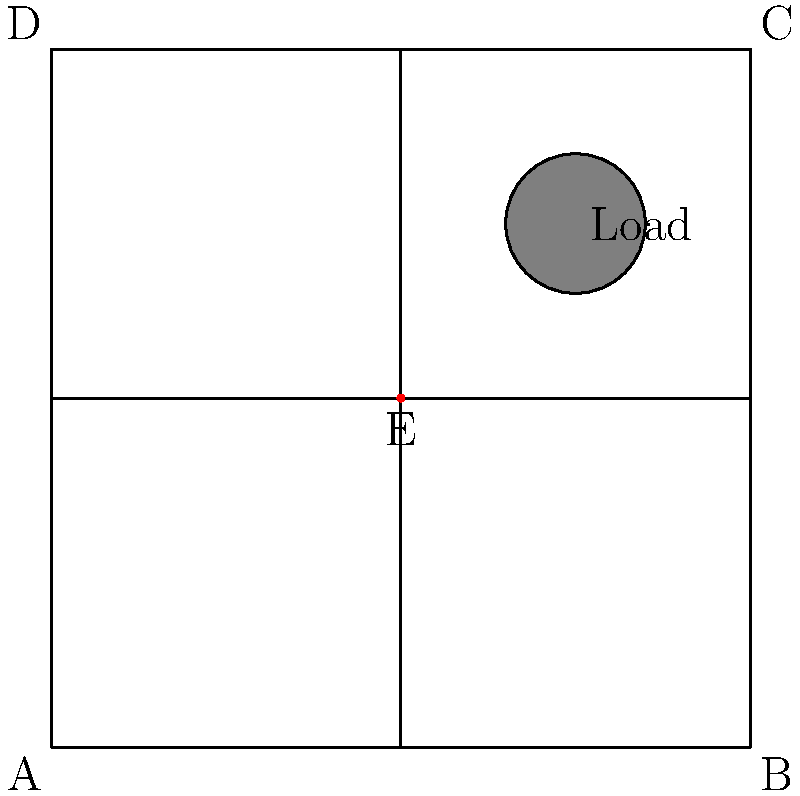Analyze the scaffolding diagram above. The structure is supporting a load at point (75,75), and joint E (50,50) has been identified as weakened. Which support member is under the most stress and at highest risk of failure? To determine which support member is under the most stress, we need to consider the following factors:

1. Load position: The load is located at (75,75), which is in the upper-right quadrant of the scaffold.

2. Weakened joint: Joint E at (50,50) is identified as weakened, which affects the stability of the entire structure.

3. Load distribution: The weight of the load will be distributed through the scaffold structure, with more stress on the members closer to the load.

4. Support member analysis:
   a) Vertical member BC: Directly beneath the load, supporting a significant portion of the weight.
   b) Horizontal member CD: Helps distribute the load but is not directly under it.
   c) Diagonal member EC: Connects the weakened joint E to the upper-right corner C, near the load.

5. Critical factors:
   - The diagonal member EC is connected to the weakened joint E.
   - EC is also the closest support to the load position.
   - The combination of the weakened joint and proximity to the load puts the most stress on EC.

Therefore, the diagonal support member EC is under the most stress and at the highest risk of failure due to its connection to the weakened joint and its proximity to the load.
Answer: Diagonal support member EC 